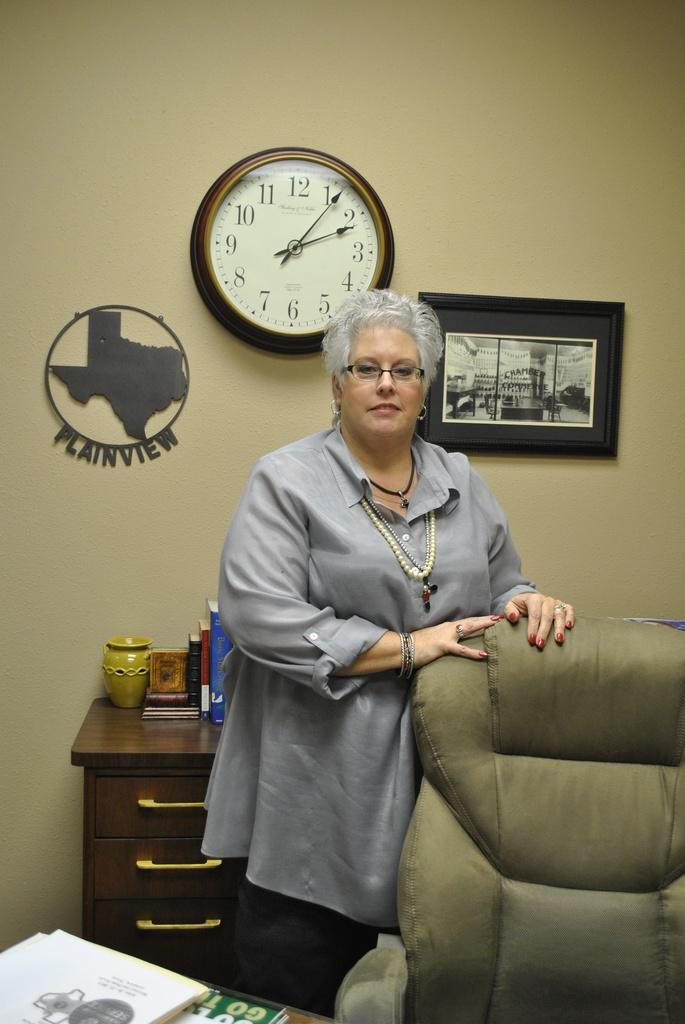<image>
Relay a brief, clear account of the picture shown. A woman stands in front of a sign on the wall that says Plainview. 